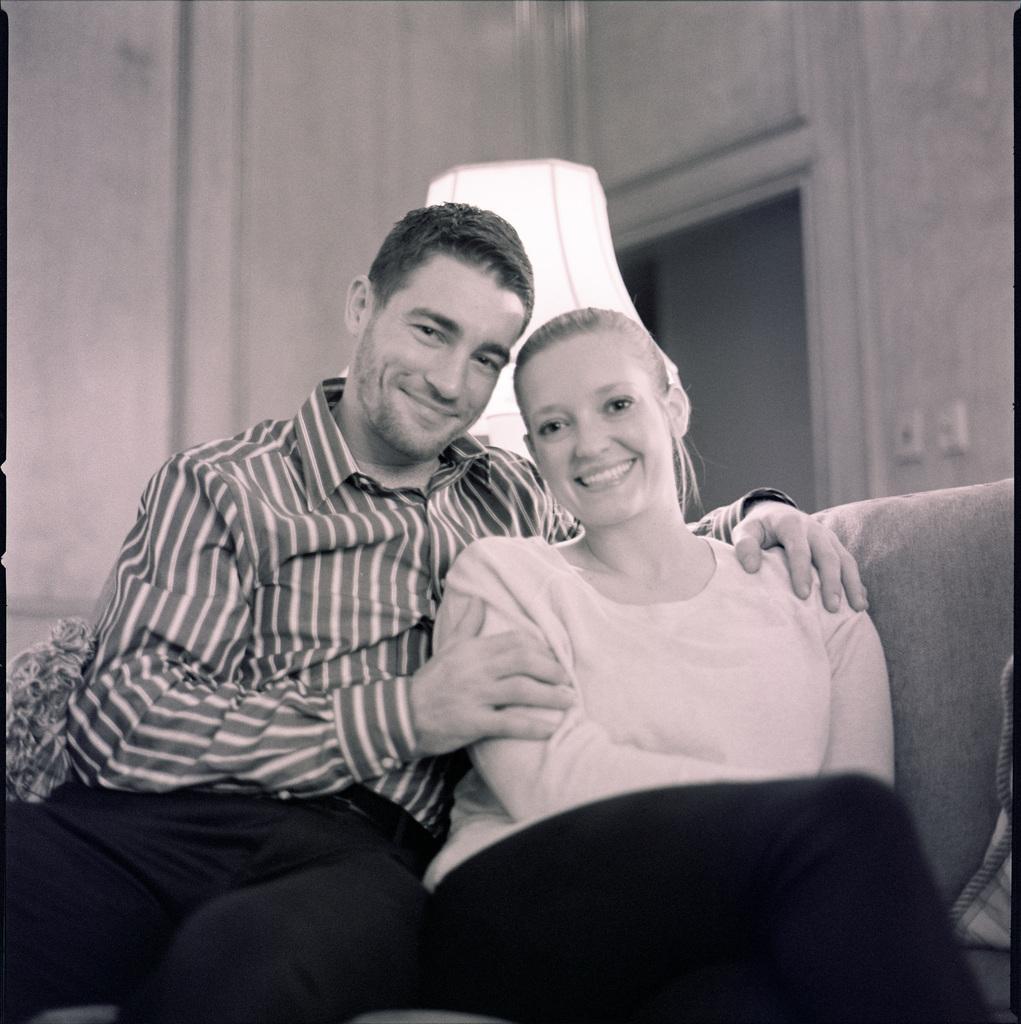Describe this image in one or two sentences. This is a black and white picture. Here we can see a man and a woman sitting on a couch and they are smiling. In the background we can see a lamp and wall. 